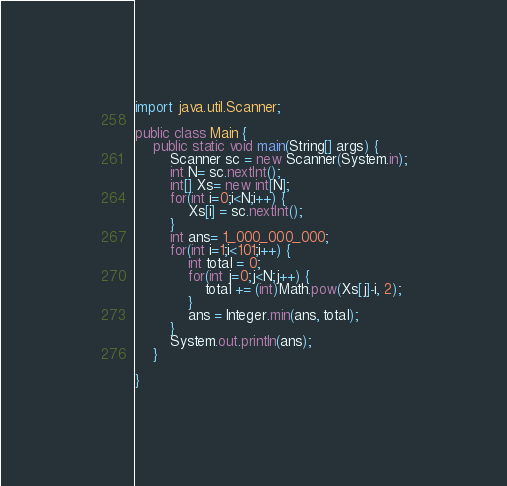<code> <loc_0><loc_0><loc_500><loc_500><_Java_>import java.util.Scanner;

public class Main {
	public static void main(String[] args) {
		Scanner sc = new Scanner(System.in);
		int N= sc.nextInt();
		int[] Xs= new int[N];
		for(int i=0;i<N;i++) {
			Xs[i] = sc.nextInt();
		}
		int ans= 1_000_000_000;
		for(int i=1;i<101;i++) {
			int total = 0;
			for(int j=0;j<N;j++) {
				total += (int)Math.pow(Xs[j]-i, 2);
			}
			ans = Integer.min(ans, total);
		}
		System.out.println(ans);
	}

}</code> 